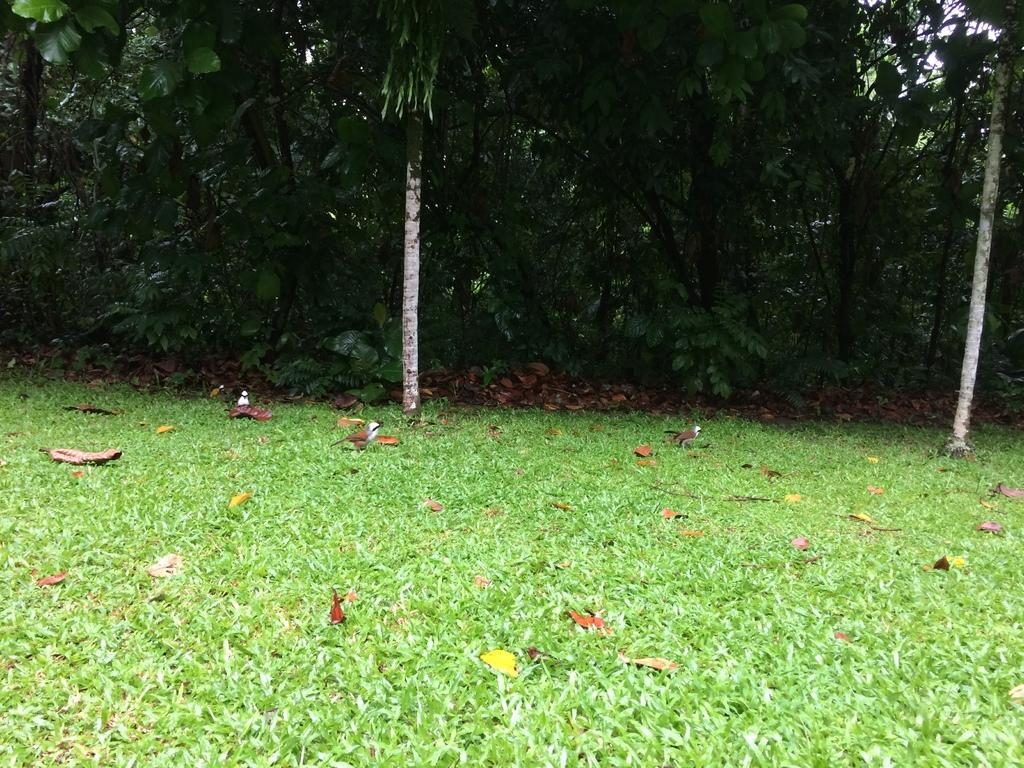What type of vegetation is present on the ground in the image? There is grass and leaves on the ground in the image. What type of animals can be seen on the ground? There are birds on the ground in the image. What can be seen in the background of the image? There are trees in the background of the image. Where is the market located in the image? There is no market present in the image. How many children are playing in the grass in the image? There are no children present in the image. 